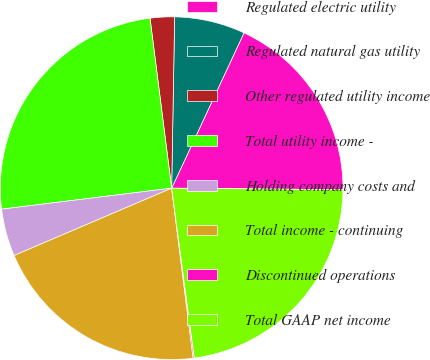<chart> <loc_0><loc_0><loc_500><loc_500><pie_chart><fcel>Regulated electric utility<fcel>Regulated natural gas utility<fcel>Other regulated utility income<fcel>Total utility income -<fcel>Holding company costs and<fcel>Total income - continuing<fcel>Discontinued operations<fcel>Total GAAP net income<nl><fcel>18.2%<fcel>6.66%<fcel>2.29%<fcel>24.94%<fcel>4.47%<fcel>20.57%<fcel>0.11%<fcel>22.75%<nl></chart> 